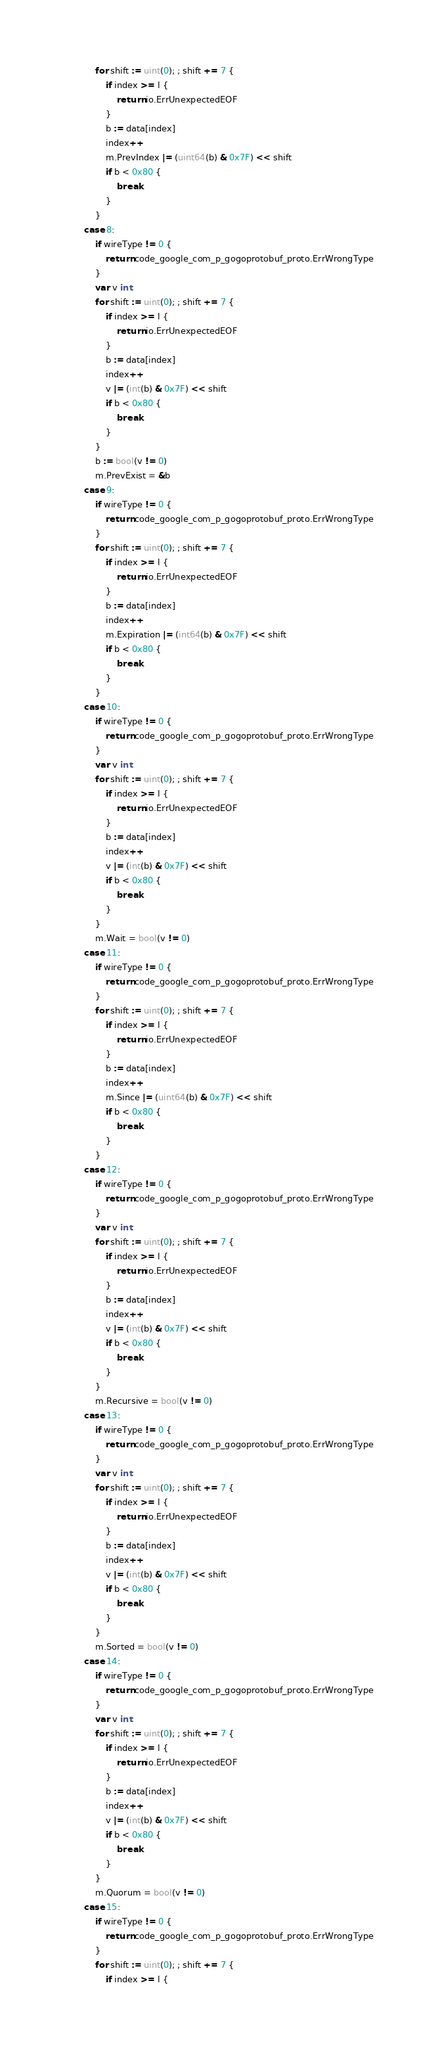Convert code to text. <code><loc_0><loc_0><loc_500><loc_500><_Go_>			for shift := uint(0); ; shift += 7 {
				if index >= l {
					return io.ErrUnexpectedEOF
				}
				b := data[index]
				index++
				m.PrevIndex |= (uint64(b) & 0x7F) << shift
				if b < 0x80 {
					break
				}
			}
		case 8:
			if wireType != 0 {
				return code_google_com_p_gogoprotobuf_proto.ErrWrongType
			}
			var v int
			for shift := uint(0); ; shift += 7 {
				if index >= l {
					return io.ErrUnexpectedEOF
				}
				b := data[index]
				index++
				v |= (int(b) & 0x7F) << shift
				if b < 0x80 {
					break
				}
			}
			b := bool(v != 0)
			m.PrevExist = &b
		case 9:
			if wireType != 0 {
				return code_google_com_p_gogoprotobuf_proto.ErrWrongType
			}
			for shift := uint(0); ; shift += 7 {
				if index >= l {
					return io.ErrUnexpectedEOF
				}
				b := data[index]
				index++
				m.Expiration |= (int64(b) & 0x7F) << shift
				if b < 0x80 {
					break
				}
			}
		case 10:
			if wireType != 0 {
				return code_google_com_p_gogoprotobuf_proto.ErrWrongType
			}
			var v int
			for shift := uint(0); ; shift += 7 {
				if index >= l {
					return io.ErrUnexpectedEOF
				}
				b := data[index]
				index++
				v |= (int(b) & 0x7F) << shift
				if b < 0x80 {
					break
				}
			}
			m.Wait = bool(v != 0)
		case 11:
			if wireType != 0 {
				return code_google_com_p_gogoprotobuf_proto.ErrWrongType
			}
			for shift := uint(0); ; shift += 7 {
				if index >= l {
					return io.ErrUnexpectedEOF
				}
				b := data[index]
				index++
				m.Since |= (uint64(b) & 0x7F) << shift
				if b < 0x80 {
					break
				}
			}
		case 12:
			if wireType != 0 {
				return code_google_com_p_gogoprotobuf_proto.ErrWrongType
			}
			var v int
			for shift := uint(0); ; shift += 7 {
				if index >= l {
					return io.ErrUnexpectedEOF
				}
				b := data[index]
				index++
				v |= (int(b) & 0x7F) << shift
				if b < 0x80 {
					break
				}
			}
			m.Recursive = bool(v != 0)
		case 13:
			if wireType != 0 {
				return code_google_com_p_gogoprotobuf_proto.ErrWrongType
			}
			var v int
			for shift := uint(0); ; shift += 7 {
				if index >= l {
					return io.ErrUnexpectedEOF
				}
				b := data[index]
				index++
				v |= (int(b) & 0x7F) << shift
				if b < 0x80 {
					break
				}
			}
			m.Sorted = bool(v != 0)
		case 14:
			if wireType != 0 {
				return code_google_com_p_gogoprotobuf_proto.ErrWrongType
			}
			var v int
			for shift := uint(0); ; shift += 7 {
				if index >= l {
					return io.ErrUnexpectedEOF
				}
				b := data[index]
				index++
				v |= (int(b) & 0x7F) << shift
				if b < 0x80 {
					break
				}
			}
			m.Quorum = bool(v != 0)
		case 15:
			if wireType != 0 {
				return code_google_com_p_gogoprotobuf_proto.ErrWrongType
			}
			for shift := uint(0); ; shift += 7 {
				if index >= l {</code> 